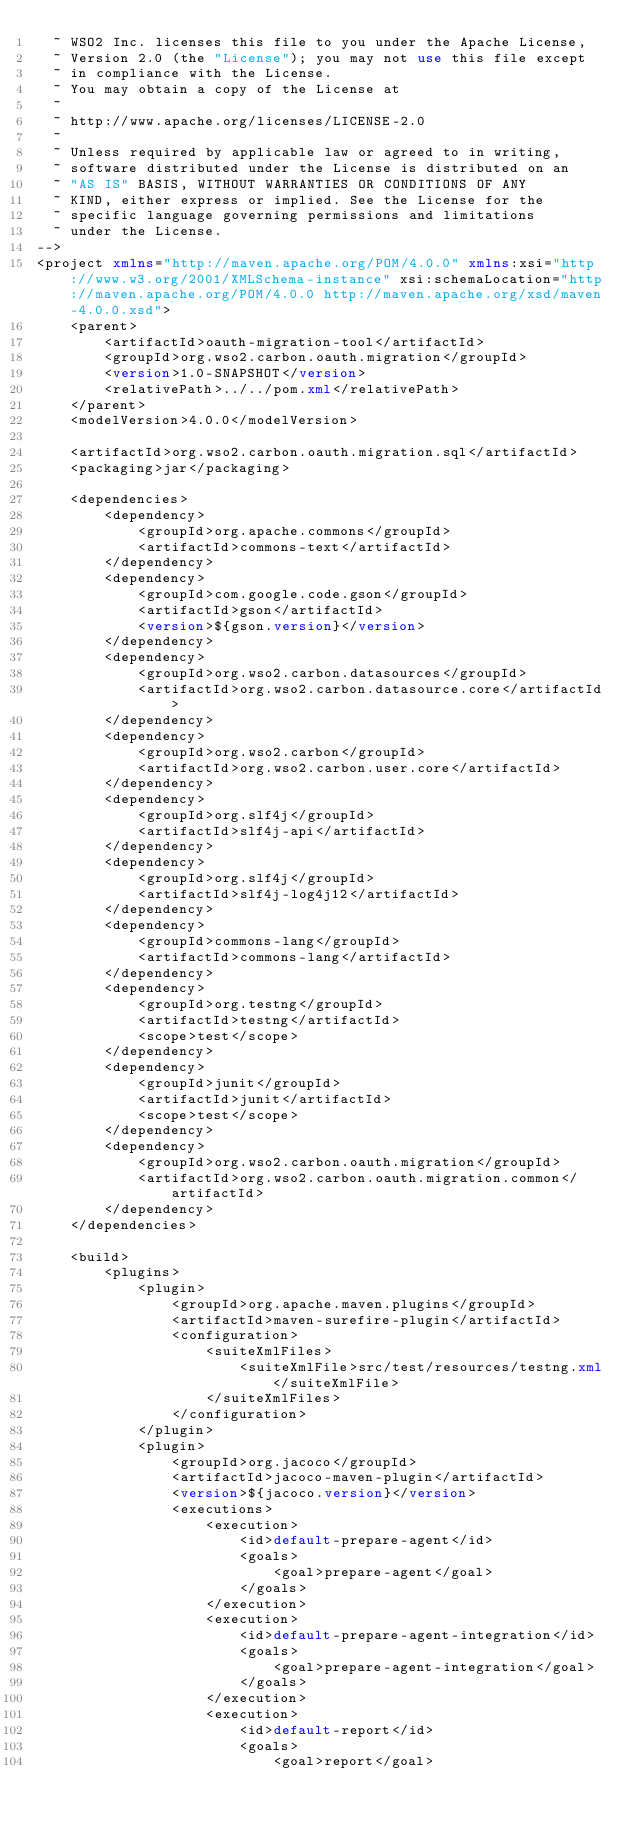<code> <loc_0><loc_0><loc_500><loc_500><_XML_>  ~ WSO2 Inc. licenses this file to you under the Apache License,
  ~ Version 2.0 (the "License"); you may not use this file except
  ~ in compliance with the License.
  ~ You may obtain a copy of the License at
  ~
  ~ http://www.apache.org/licenses/LICENSE-2.0
  ~
  ~ Unless required by applicable law or agreed to in writing,
  ~ software distributed under the License is distributed on an
  ~ "AS IS" BASIS, WITHOUT WARRANTIES OR CONDITIONS OF ANY
  ~ KIND, either express or implied. See the License for the
  ~ specific language governing permissions and limitations
  ~ under the License.
-->
<project xmlns="http://maven.apache.org/POM/4.0.0" xmlns:xsi="http://www.w3.org/2001/XMLSchema-instance" xsi:schemaLocation="http://maven.apache.org/POM/4.0.0 http://maven.apache.org/xsd/maven-4.0.0.xsd">
    <parent>
        <artifactId>oauth-migration-tool</artifactId>
        <groupId>org.wso2.carbon.oauth.migration</groupId>
        <version>1.0-SNAPSHOT</version>
        <relativePath>../../pom.xml</relativePath>
    </parent>
    <modelVersion>4.0.0</modelVersion>

    <artifactId>org.wso2.carbon.oauth.migration.sql</artifactId>
    <packaging>jar</packaging>

    <dependencies>
        <dependency>
            <groupId>org.apache.commons</groupId>
            <artifactId>commons-text</artifactId>
        </dependency>
        <dependency>
            <groupId>com.google.code.gson</groupId>
            <artifactId>gson</artifactId>
            <version>${gson.version}</version>
        </dependency>
        <dependency>
            <groupId>org.wso2.carbon.datasources</groupId>
            <artifactId>org.wso2.carbon.datasource.core</artifactId>
        </dependency>
        <dependency>
            <groupId>org.wso2.carbon</groupId>
            <artifactId>org.wso2.carbon.user.core</artifactId>
        </dependency>
        <dependency>
            <groupId>org.slf4j</groupId>
            <artifactId>slf4j-api</artifactId>
        </dependency>
        <dependency>
            <groupId>org.slf4j</groupId>
            <artifactId>slf4j-log4j12</artifactId>
        </dependency>
        <dependency>
            <groupId>commons-lang</groupId>
            <artifactId>commons-lang</artifactId>
        </dependency>
        <dependency>
            <groupId>org.testng</groupId>
            <artifactId>testng</artifactId>
            <scope>test</scope>
        </dependency>
        <dependency>
            <groupId>junit</groupId>
            <artifactId>junit</artifactId>
            <scope>test</scope>
        </dependency>
        <dependency>
            <groupId>org.wso2.carbon.oauth.migration</groupId>
            <artifactId>org.wso2.carbon.oauth.migration.common</artifactId>
        </dependency>
    </dependencies>

    <build>
        <plugins>
            <plugin>
                <groupId>org.apache.maven.plugins</groupId>
                <artifactId>maven-surefire-plugin</artifactId>
                <configuration>
                    <suiteXmlFiles>
                        <suiteXmlFile>src/test/resources/testng.xml</suiteXmlFile>
                    </suiteXmlFiles>
                </configuration>
            </plugin>
            <plugin>
                <groupId>org.jacoco</groupId>
                <artifactId>jacoco-maven-plugin</artifactId>
                <version>${jacoco.version}</version>
                <executions>
                    <execution>
                        <id>default-prepare-agent</id>
                        <goals>
                            <goal>prepare-agent</goal>
                        </goals>
                    </execution>
                    <execution>
                        <id>default-prepare-agent-integration</id>
                        <goals>
                            <goal>prepare-agent-integration</goal>
                        </goals>
                    </execution>
                    <execution>
                        <id>default-report</id>
                        <goals>
                            <goal>report</goal></code> 